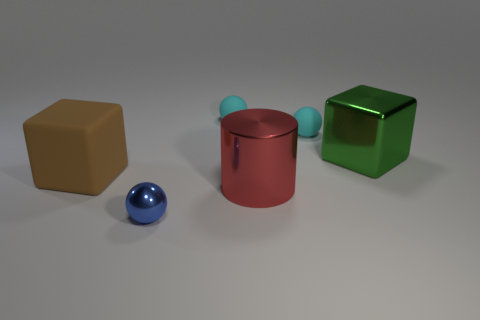Subtract all tiny metallic spheres. How many spheres are left? 2 Subtract all cylinders. How many objects are left? 5 Add 3 big brown matte cubes. How many objects exist? 9 Subtract all big green blocks. Subtract all large red shiny cylinders. How many objects are left? 4 Add 6 cyan matte balls. How many cyan matte balls are left? 8 Add 3 metallic cylinders. How many metallic cylinders exist? 4 Subtract all blue balls. How many balls are left? 2 Subtract 1 blue balls. How many objects are left? 5 Subtract 1 blocks. How many blocks are left? 1 Subtract all red blocks. Subtract all gray balls. How many blocks are left? 2 